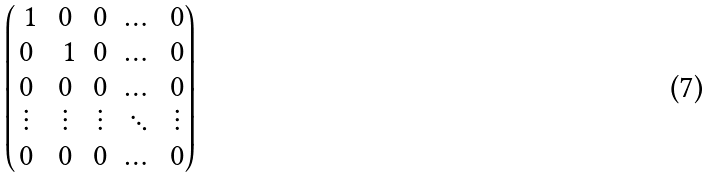<formula> <loc_0><loc_0><loc_500><loc_500>\begin{pmatrix} \ 1 & 0 & 0 & \dots & 0 \\ 0 & \ 1 & 0 & \dots & 0 \\ 0 & 0 & 0 & \dots & 0 \\ \vdots & \vdots & \vdots & \ddots & \vdots \\ 0 & 0 & 0 & \dots & 0 \\ \end{pmatrix}</formula> 